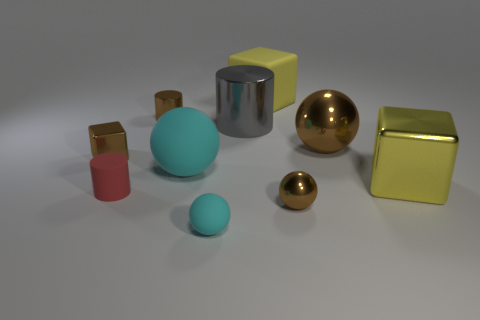Add 5 brown matte cylinders. How many brown matte cylinders exist? 5 Subtract all brown cylinders. How many cylinders are left? 2 Subtract all yellow blocks. How many blocks are left? 1 Subtract 1 cyan spheres. How many objects are left? 9 Subtract all blocks. How many objects are left? 7 Subtract 1 cylinders. How many cylinders are left? 2 Subtract all yellow balls. Subtract all green cylinders. How many balls are left? 4 Subtract all red cylinders. How many yellow cubes are left? 2 Subtract all cylinders. Subtract all shiny things. How many objects are left? 1 Add 9 gray metal cylinders. How many gray metal cylinders are left? 10 